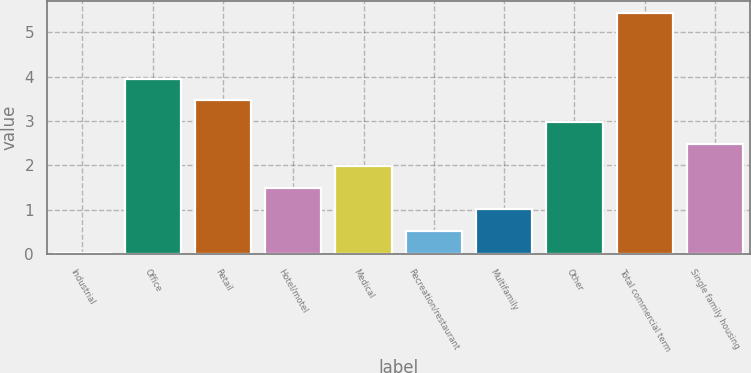Convert chart. <chart><loc_0><loc_0><loc_500><loc_500><bar_chart><fcel>Industrial<fcel>Office<fcel>Retail<fcel>Hotel/motel<fcel>Medical<fcel>Recreation/restaurant<fcel>Multifamily<fcel>Other<fcel>Total commercial term<fcel>Single family housing<nl><fcel>0.03<fcel>3.95<fcel>3.46<fcel>1.5<fcel>1.99<fcel>0.52<fcel>1.01<fcel>2.97<fcel>5.42<fcel>2.48<nl></chart> 